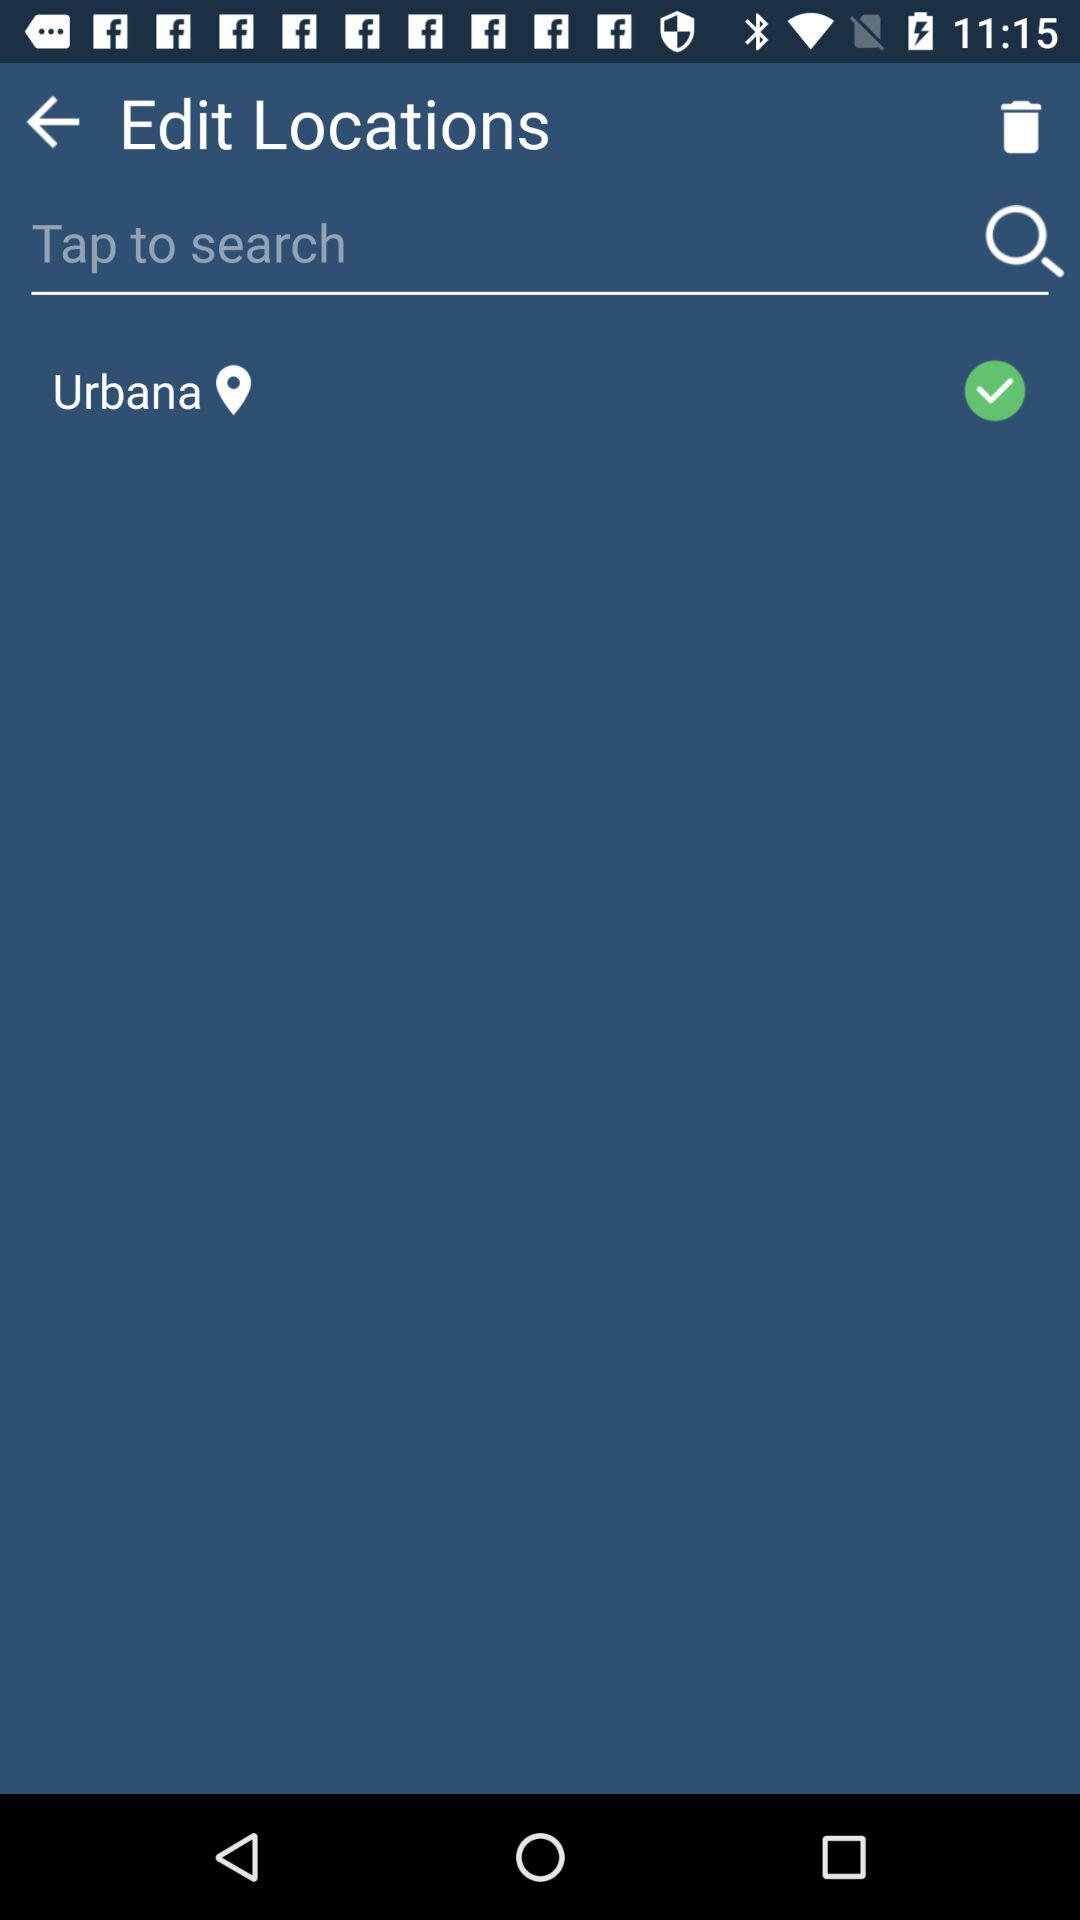Which location is selected? The selected location is Urbana. 